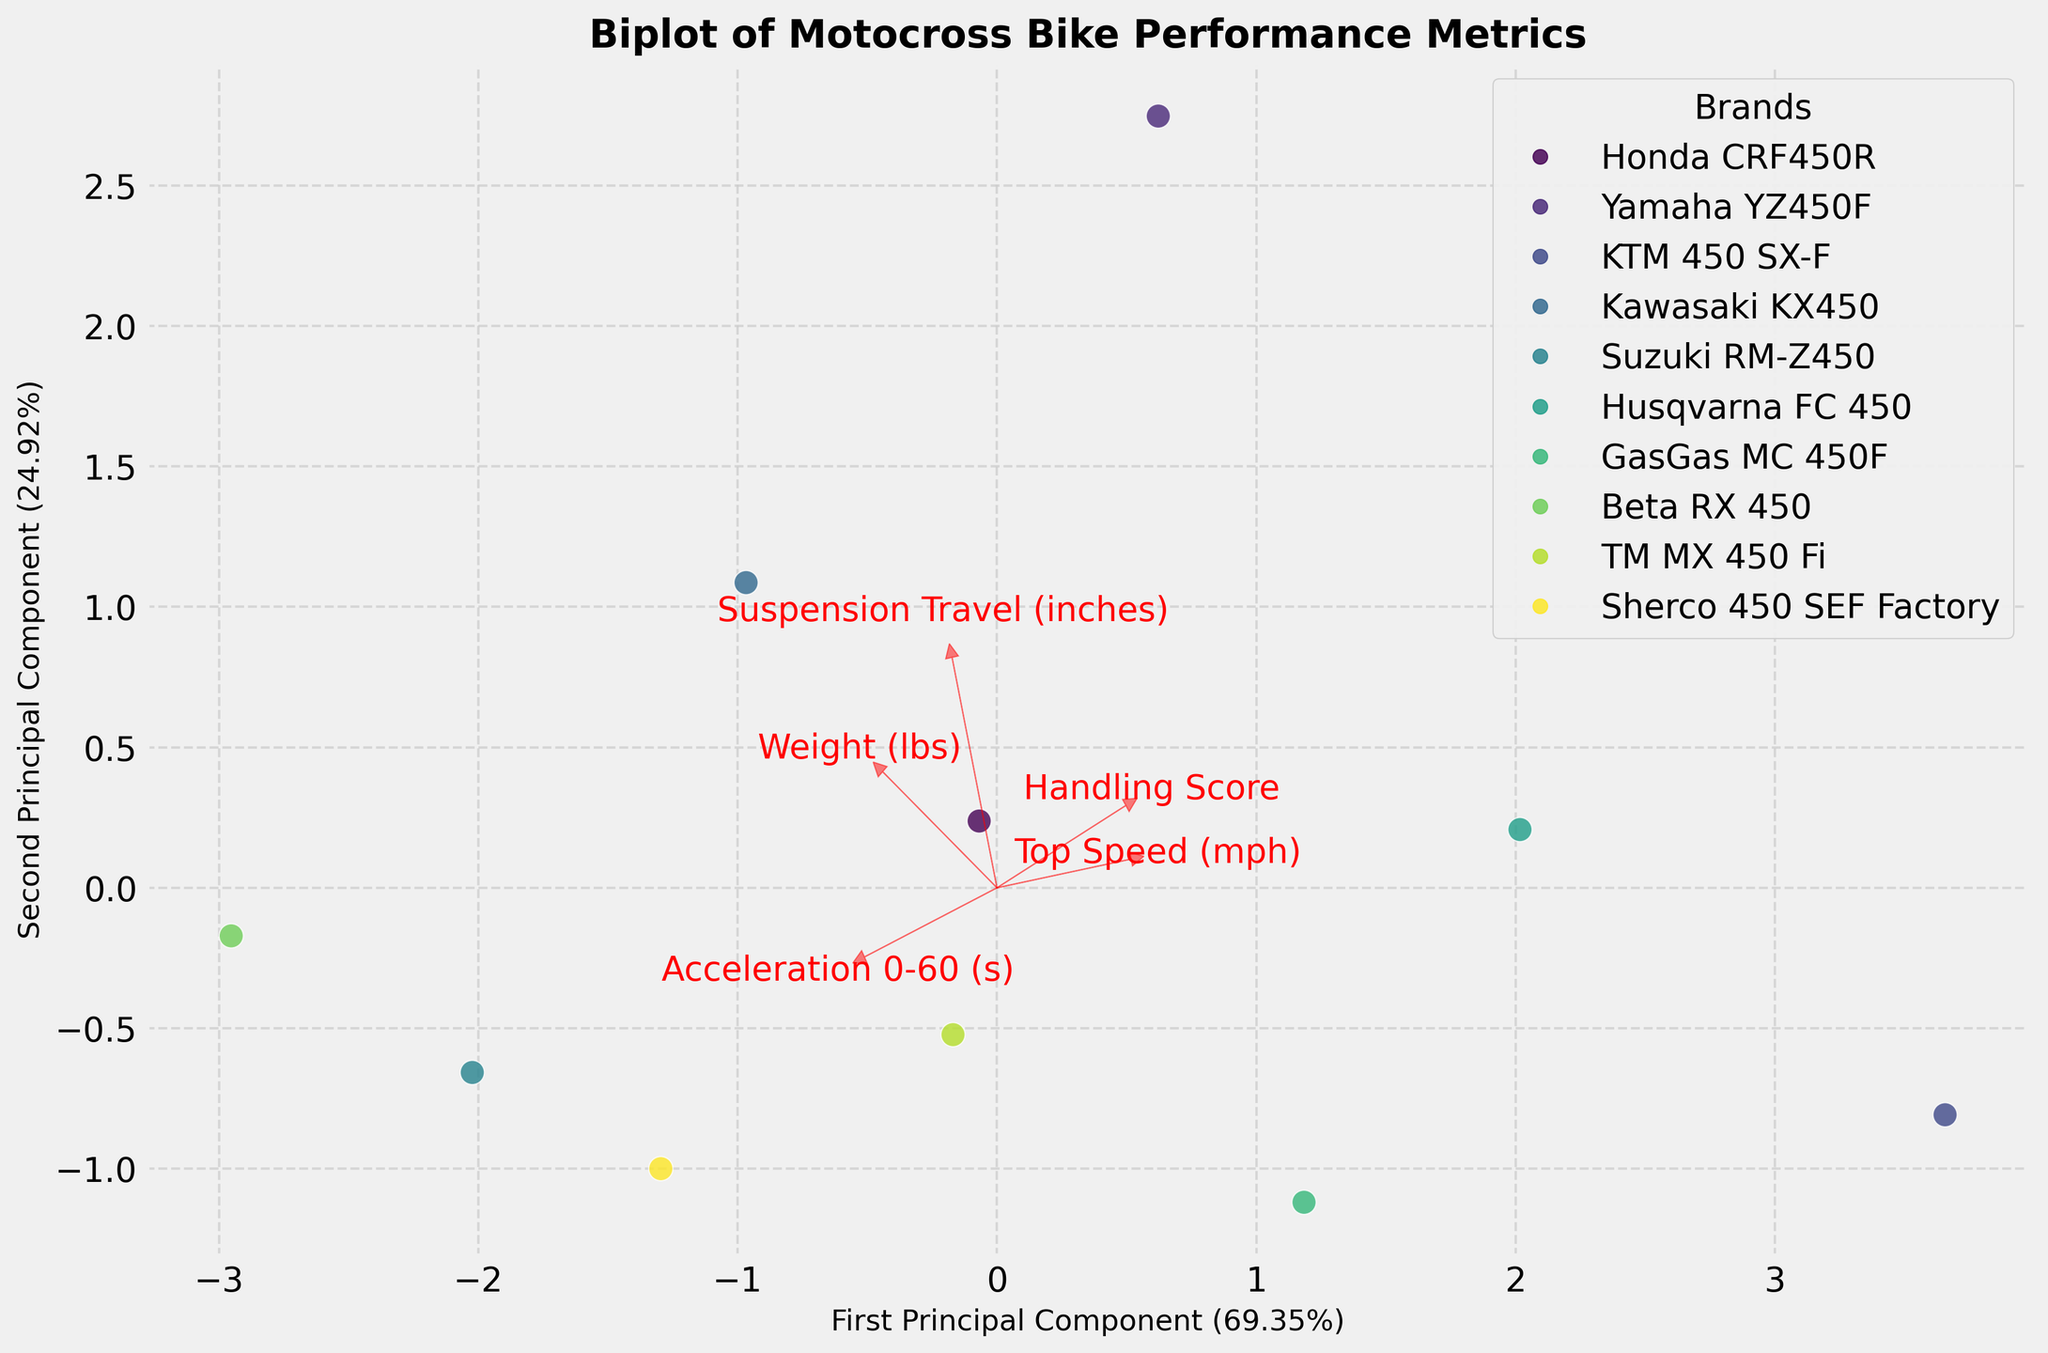How many different brands of motocross bikes are represented in this Biplot? By looking at the legend, we can count the different icons representing each brand.
Answer: 10 What is the title of the Biplot? The title of the Biplot is displayed at the top of the figure.
Answer: Biplot of Motocross Bike Performance Metrics Which principal component explains the most variance in the data? The axis labels provide the percentage of variance explained by each principal component. The first principal component has a higher percentage.
Answer: First Principal Component Which brand has the highest Top Speed (mph)? By observing the position of brands relative to the vector representing 'Top Speed (mph)', we see which brand is furthest along this vector.
Answer: KTM 450 SX-F How do the handling scores differ between Yamaha YZ450F and Suzuki RM-Z450? Look at the positions of Yamaha YZ450F and Suzuki RM-Z450 relative to the 'Handling Score' vector; Yamaha YZ450F is closer to the higher end.
Answer: Yamaha YZ450F has a better handling score Which feature vector is most aligned with the second principal component? By observing the vectors, we can see which red arrow is most aligned with the y-axis representing the second principal component.
Answer: Weight (lbs) Are the majority of brands clustered closely together or spread apart? By observing the spread of the data points on the Biplot, we can determine the clustering tendency.
Answer: Clustered closely together Which two features are most correlated according to the Biplot? Features that have vectors pointing in similar directions indicate high correlation.
Answer: Acceleration 0-60 (s) and Handling Score How is the suspension travel of the Honda CRF450R compared to the GasGas MC 450F? By examining their positions relative to the 'Suspension Travel (inches)' vector, we can see how these two brands compare.
Answer: Honda CRF450R has slightly better suspension travel If you were to pick a bike with the best combination of speed and handling, which one would it be? Finding a brand close to the direction of both the 'Top Speed (mph)' and 'Handling Score' vectors ensures the best combination.
Answer: KTM 450 SX-F 